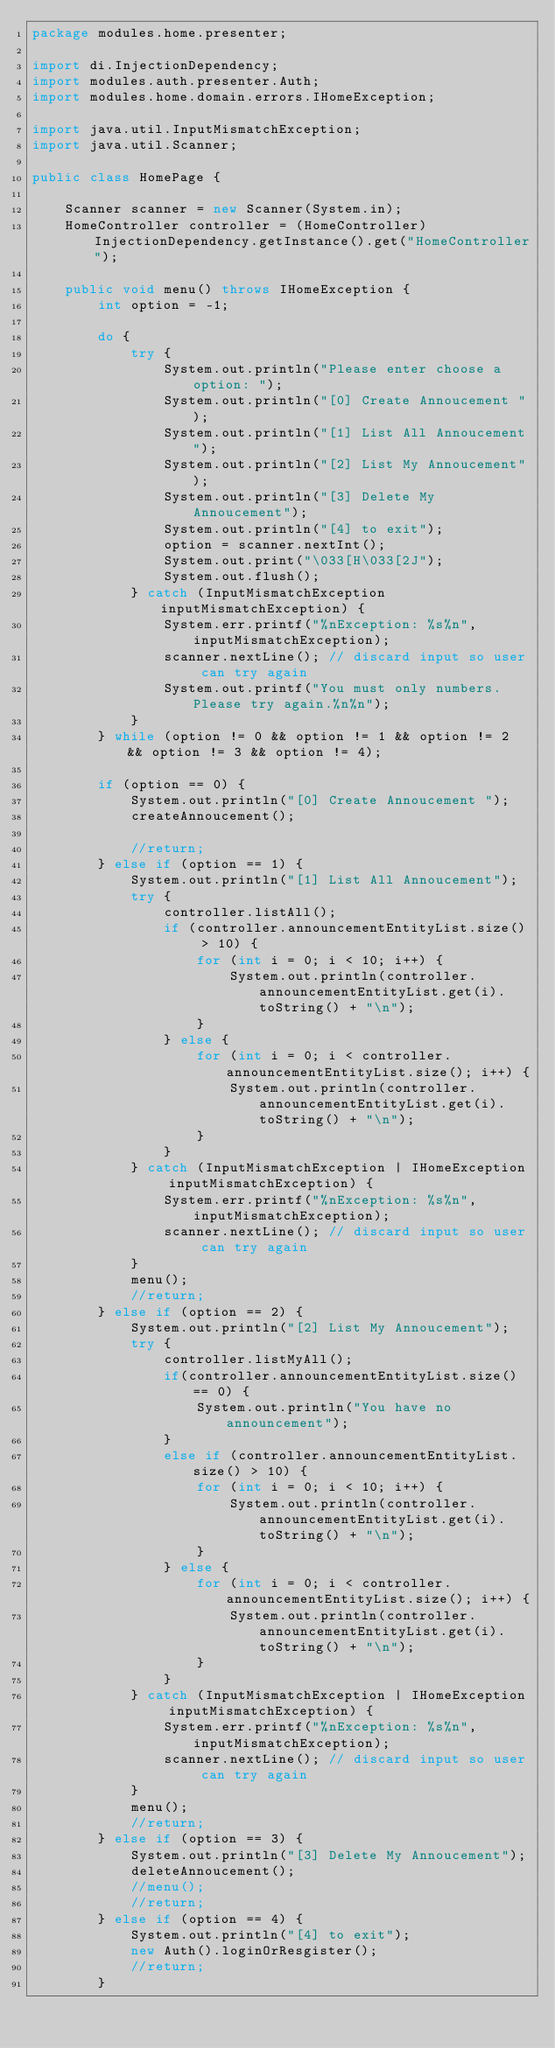Convert code to text. <code><loc_0><loc_0><loc_500><loc_500><_Java_>package modules.home.presenter;

import di.InjectionDependency;
import modules.auth.presenter.Auth;
import modules.home.domain.errors.IHomeException;

import java.util.InputMismatchException;
import java.util.Scanner;

public class HomePage {

    Scanner scanner = new Scanner(System.in);
    HomeController controller = (HomeController) InjectionDependency.getInstance().get("HomeController");

    public void menu() throws IHomeException {
        int option = -1;

        do {
            try {
                System.out.println("Please enter choose a option: ");
                System.out.println("[0] Create Annoucement ");
                System.out.println("[1] List All Annoucement");
                System.out.println("[2] List My Annoucement");
                System.out.println("[3] Delete My Annoucement");
                System.out.println("[4] to exit");
                option = scanner.nextInt();
                System.out.print("\033[H\033[2J");
                System.out.flush();
            } catch (InputMismatchException inputMismatchException) {
                System.err.printf("%nException: %s%n", inputMismatchException);
                scanner.nextLine(); // discard input so user can try again
                System.out.printf("You must only numbers. Please try again.%n%n");
            }
        } while (option != 0 && option != 1 && option != 2 && option != 3 && option != 4);

        if (option == 0) {
            System.out.println("[0] Create Annoucement ");
            createAnnoucement();

            //return;
        } else if (option == 1) {
            System.out.println("[1] List All Annoucement");
            try {
                controller.listAll();
                if (controller.announcementEntityList.size() > 10) {
                    for (int i = 0; i < 10; i++) {
                        System.out.println(controller.announcementEntityList.get(i).toString() + "\n");
                    }
                } else {
                    for (int i = 0; i < controller.announcementEntityList.size(); i++) {
                        System.out.println(controller.announcementEntityList.get(i).toString() + "\n");
                    }
                }
            } catch (InputMismatchException | IHomeException inputMismatchException) {
                System.err.printf("%nException: %s%n", inputMismatchException);
                scanner.nextLine(); // discard input so user can try again
            }
            menu();
            //return;
        } else if (option == 2) {
            System.out.println("[2] List My Annoucement");
            try {
                controller.listMyAll();
                if(controller.announcementEntityList.size() == 0) {
                    System.out.println("You have no announcement");
                }
                else if (controller.announcementEntityList.size() > 10) {
                    for (int i = 0; i < 10; i++) {
                        System.out.println(controller.announcementEntityList.get(i).toString() + "\n");
                    }
                } else {
                    for (int i = 0; i < controller.announcementEntityList.size(); i++) {
                        System.out.println(controller.announcementEntityList.get(i).toString() + "\n");
                    }
                }
            } catch (InputMismatchException | IHomeException inputMismatchException) {
                System.err.printf("%nException: %s%n", inputMismatchException);
                scanner.nextLine(); // discard input so user can try again
            }
            menu();
            //return;
        } else if (option == 3) {
            System.out.println("[3] Delete My Annoucement");
            deleteAnnoucement();
            //menu();
            //return;
        } else if (option == 4) {
            System.out.println("[4] to exit");
            new Auth().loginOrResgister();
            //return;
        }</code> 